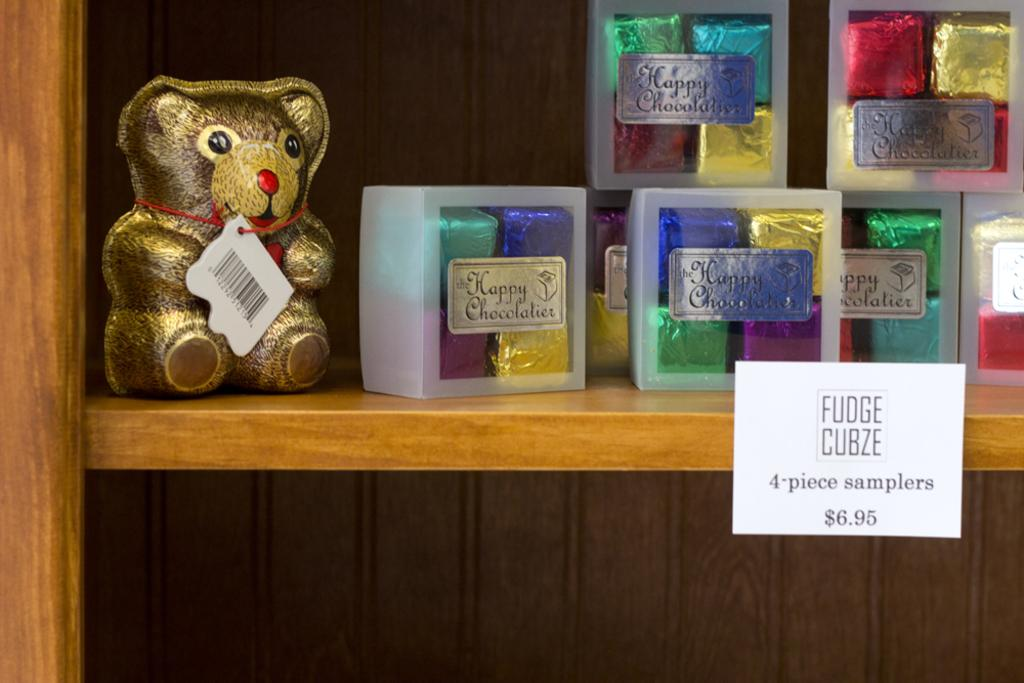<image>
Describe the image concisely. A shelf has a sign attached advertising Fudge Cubze samplers. 